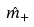Convert formula to latex. <formula><loc_0><loc_0><loc_500><loc_500>\hat { m } _ { + }</formula> 